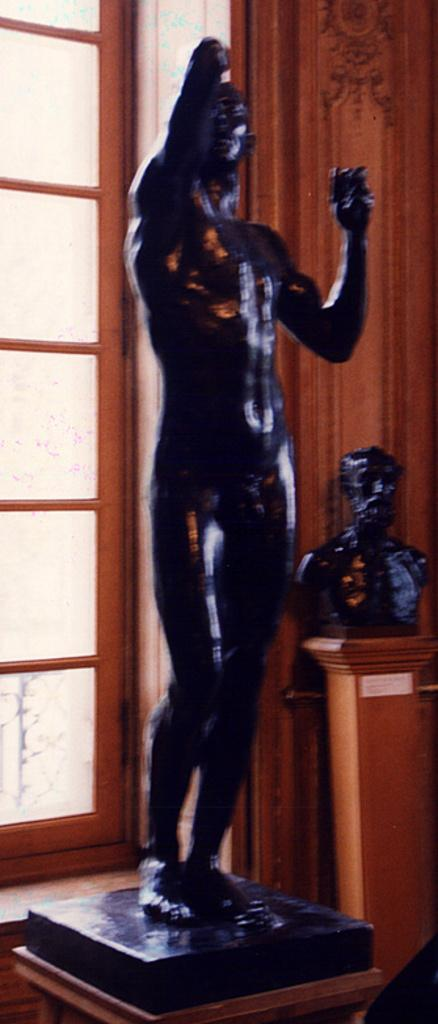What is the main object in the image? There is an idol in black color in the image. What can be seen on the left side of the image? There is a door on the left side of the image. What is located on the right side of the image? There is a statue on a wooden block on the right side of the image. What type of plate is being used to carry the statue in the image? There is no plate or carriage present in the image; the statue is on a wooden block. 